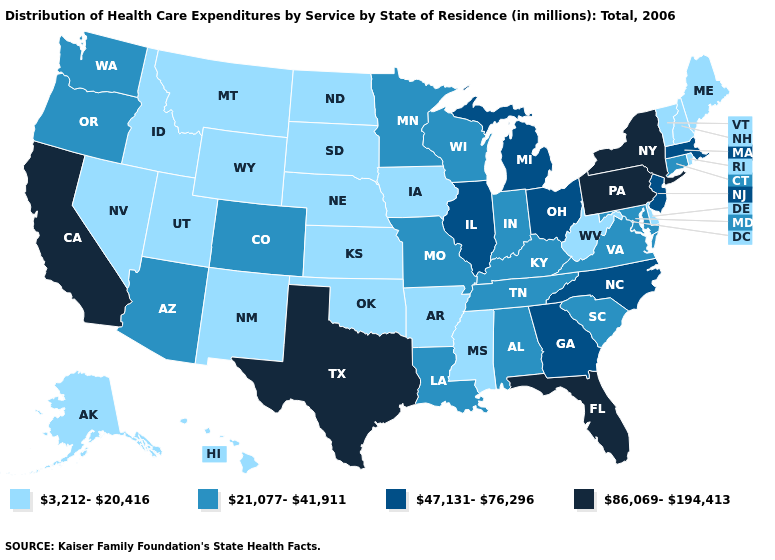Which states have the lowest value in the MidWest?
Give a very brief answer. Iowa, Kansas, Nebraska, North Dakota, South Dakota. Does the first symbol in the legend represent the smallest category?
Quick response, please. Yes. Name the states that have a value in the range 3,212-20,416?
Write a very short answer. Alaska, Arkansas, Delaware, Hawaii, Idaho, Iowa, Kansas, Maine, Mississippi, Montana, Nebraska, Nevada, New Hampshire, New Mexico, North Dakota, Oklahoma, Rhode Island, South Dakota, Utah, Vermont, West Virginia, Wyoming. What is the lowest value in the USA?
Keep it brief. 3,212-20,416. Which states hav the highest value in the Northeast?
Concise answer only. New York, Pennsylvania. What is the value of New Mexico?
Short answer required. 3,212-20,416. Among the states that border Delaware , which have the lowest value?
Quick response, please. Maryland. What is the lowest value in the West?
Concise answer only. 3,212-20,416. Does the first symbol in the legend represent the smallest category?
Give a very brief answer. Yes. Does Kansas have the same value as New Mexico?
Be succinct. Yes. What is the value of Ohio?
Keep it brief. 47,131-76,296. What is the highest value in the MidWest ?
Be succinct. 47,131-76,296. Name the states that have a value in the range 21,077-41,911?
Concise answer only. Alabama, Arizona, Colorado, Connecticut, Indiana, Kentucky, Louisiana, Maryland, Minnesota, Missouri, Oregon, South Carolina, Tennessee, Virginia, Washington, Wisconsin. What is the highest value in the USA?
Short answer required. 86,069-194,413. Name the states that have a value in the range 86,069-194,413?
Quick response, please. California, Florida, New York, Pennsylvania, Texas. 